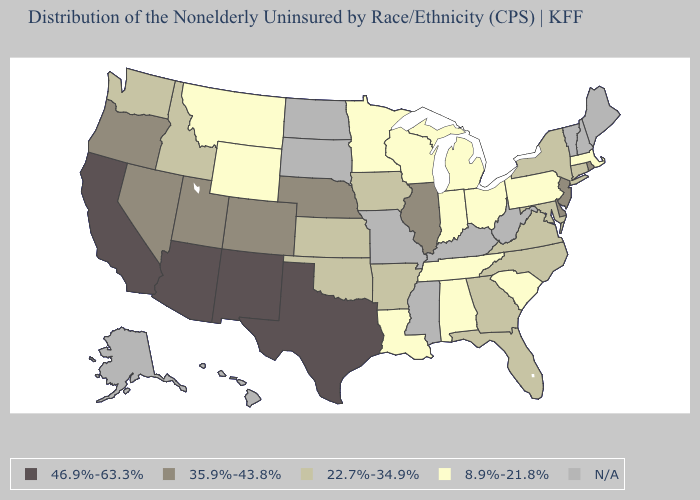What is the highest value in the USA?
Give a very brief answer. 46.9%-63.3%. Does California have the lowest value in the USA?
Short answer required. No. Which states have the lowest value in the USA?
Answer briefly. Alabama, Indiana, Louisiana, Massachusetts, Michigan, Minnesota, Montana, Ohio, Pennsylvania, South Carolina, Tennessee, Wisconsin, Wyoming. What is the value of Nevada?
Answer briefly. 35.9%-43.8%. What is the lowest value in the USA?
Short answer required. 8.9%-21.8%. Name the states that have a value in the range 46.9%-63.3%?
Quick response, please. Arizona, California, New Mexico, Texas. What is the highest value in the USA?
Short answer required. 46.9%-63.3%. Is the legend a continuous bar?
Write a very short answer. No. Which states hav the highest value in the Northeast?
Be succinct. New Jersey, Rhode Island. Among the states that border Minnesota , does Iowa have the lowest value?
Short answer required. No. What is the lowest value in the USA?
Keep it brief. 8.9%-21.8%. Does the first symbol in the legend represent the smallest category?
Keep it brief. No. What is the lowest value in the South?
Concise answer only. 8.9%-21.8%. What is the value of Nevada?
Keep it brief. 35.9%-43.8%. What is the value of New York?
Write a very short answer. 22.7%-34.9%. 